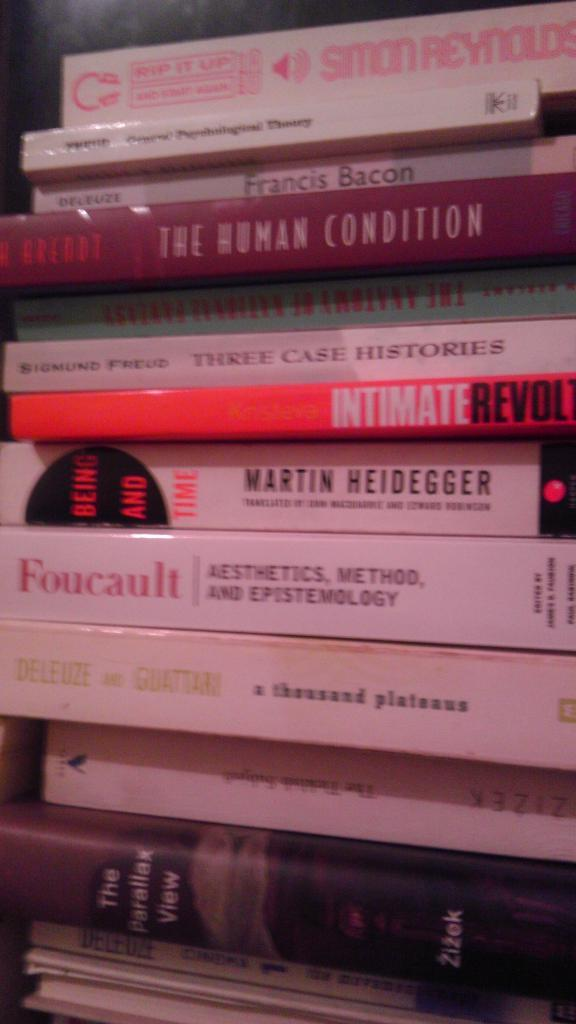<image>
Share a concise interpretation of the image provided. the word foucault is on the white book 